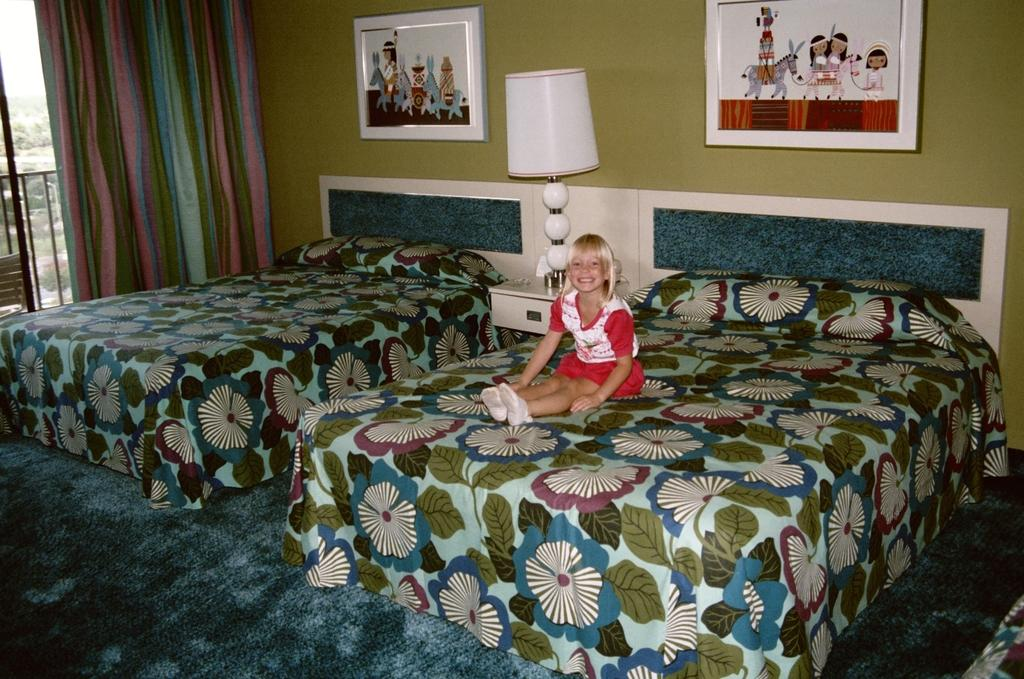What is the girl doing in the image? The girl is sitting on the bed in the image. What object is near the girl? There is a lamp near the girl. What can be seen on the wall in the image? There are photo frames on the wall in the image. What type of activity is happening at the airport in the image? There is no airport or any activity related to an airport present in the image. 